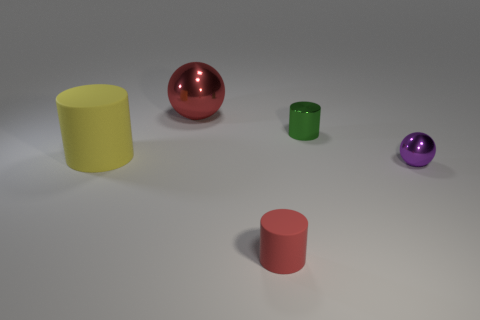The yellow object that is the same size as the red metal thing is what shape?
Provide a succinct answer. Cylinder. Are there more tiny green shiny cylinders than small cyan matte cubes?
Offer a terse response. Yes. What is the tiny object that is both in front of the big cylinder and behind the red rubber object made of?
Offer a terse response. Metal. What number of other things are made of the same material as the big yellow cylinder?
Make the answer very short. 1. What number of big spheres have the same color as the large matte cylinder?
Provide a succinct answer. 0. There is a ball that is to the left of the green metallic cylinder left of the shiny thing that is in front of the big cylinder; what is its size?
Provide a short and direct response. Large. What number of metallic objects are big yellow cylinders or small objects?
Provide a short and direct response. 2. There is a purple shiny thing; is its shape the same as the matte thing that is in front of the small purple ball?
Offer a very short reply. No. Is the number of purple balls that are on the left side of the purple object greater than the number of tiny purple balls that are left of the red sphere?
Make the answer very short. No. Is there anything else that is the same color as the large cylinder?
Give a very brief answer. No. 